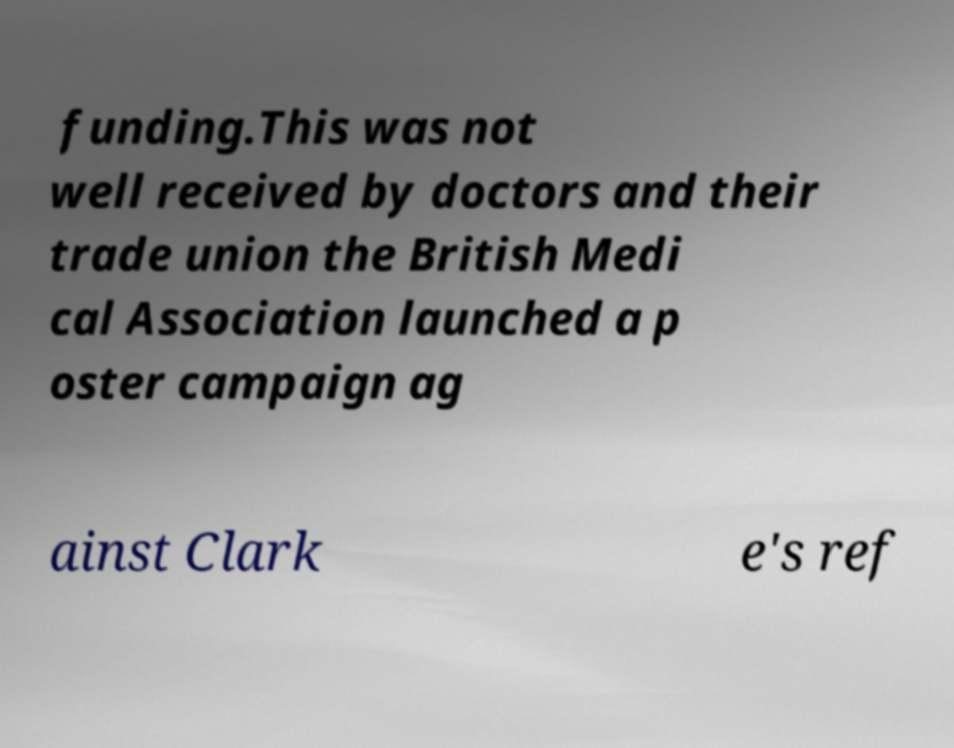Could you extract and type out the text from this image? funding.This was not well received by doctors and their trade union the British Medi cal Association launched a p oster campaign ag ainst Clark e's ref 